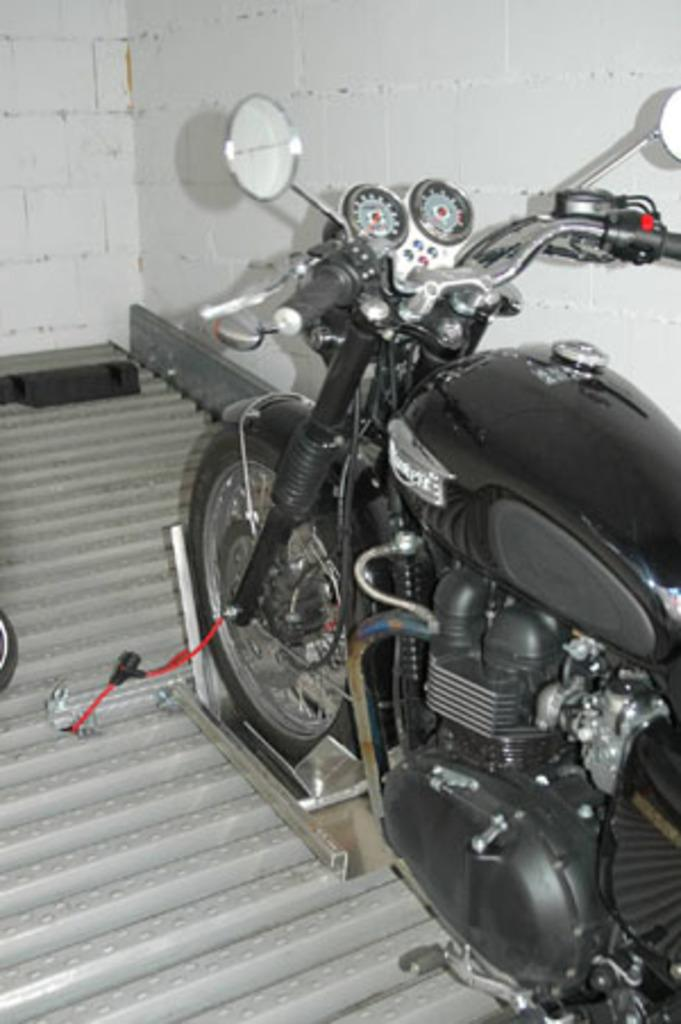What is the main subject in the image? There is a vehicle in the image. What can be seen beneath the vehicle? The ground is visible in the image. What is present on the ground in the image? There are objects on the ground. What is located on the right side of the image? There is a wall in the image. What is on the left side of the image? There is an object on the left side of the image. How does the baby interact with the vehicle in the image? There is no baby present in the image. --- Facts: 1. There is a person in the image. 2. The person is wearing a hat. 3. The person is holding a book. 4. There is a table in the image. 5. The table has a laptop on it. Absurd Topics: elephant, parrot, ocean Conversation: What is the main subject in the image? There is a person in the image. What is the person wearing in the image? The person is wearing a hat in the image. What is the person holding in the image? The person is holding a book in the image. What is present on the table in the image? There is a laptop on the table in the image. Reasoning: Let's think step by step in order to produce the conversation. We start by identifying the main subject of the image, which is the person. Then, we describe specific details about the person, such as the hat and the book they are holding. Next, we observe the objects present on the table, noting that there is a laptop on it. Absurd Question/Answer: How many elephants can be seen swimming in the ocean in the image? There are no elephants present in the image. --- Facts: 1. There is a group of people in the image. 2. The people are wearing matching t-shirts. 3. The people are holding hands. 4. There is a banner in the image. 5. The banner has a message on it. Absurd Topics: monkey, banana, fruit Conversation: What is the main subject in the image? There is a group of people in the image. What are the people wearing in the image? The people are wearing matching t-shirts in the image. What are the people doing in the image? The people are holding hands in the image. What is present in the image besides the group of people? There is a banner in the image. What message is written on the banner in the image? The banner has a message on it in the image. Reasoning: Let's think step by step in order to produce the conversation. We start by identifying the main subject of the image, 